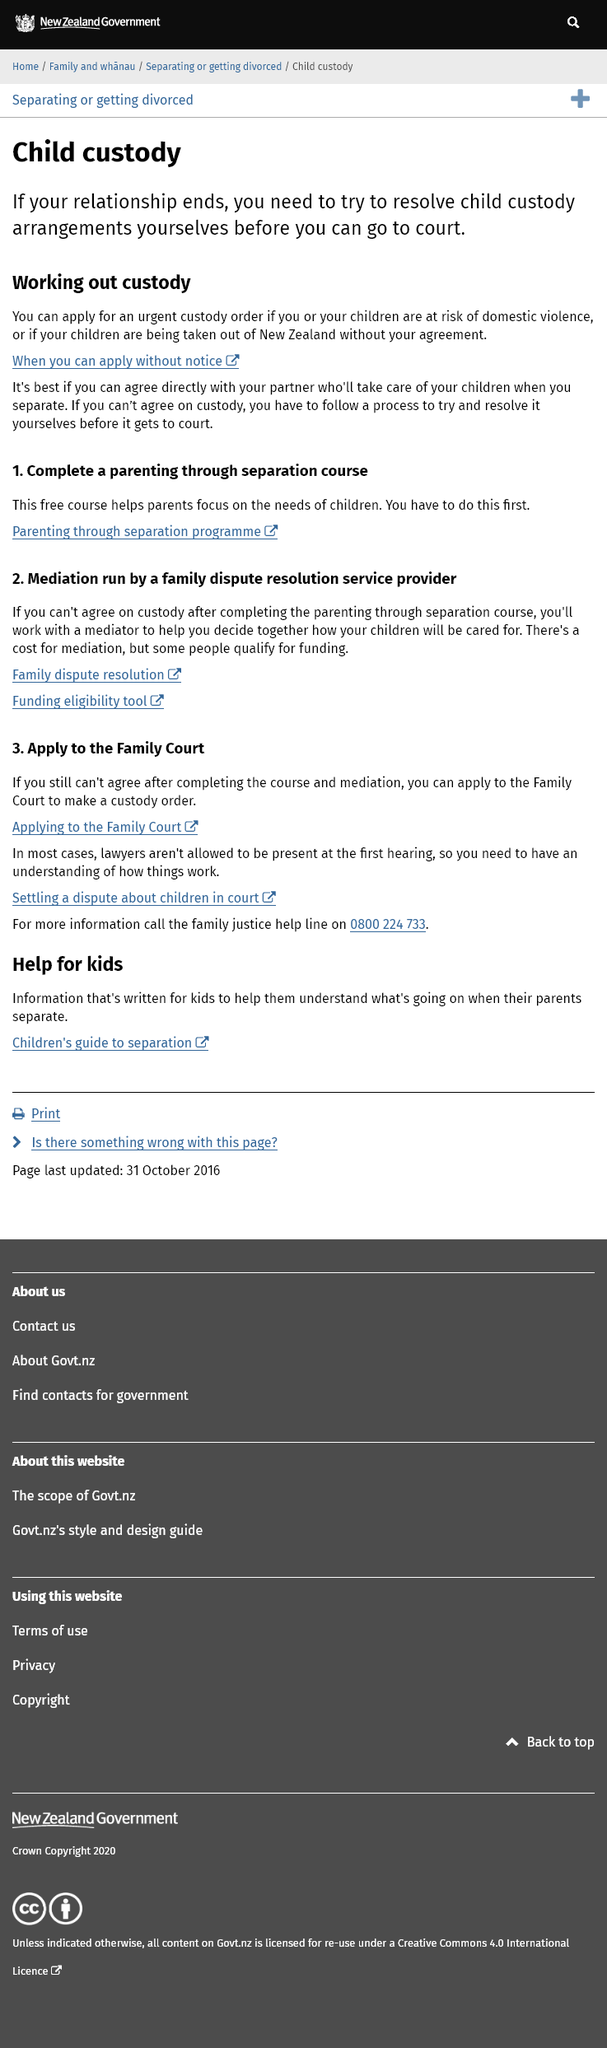Point out several critical features in this image. It is possible to apply for an urgent custody order if a relationship ends, but only under certain conditions. It is advisable to attempt to reach a resolution on child custody arrangements before going to court. 